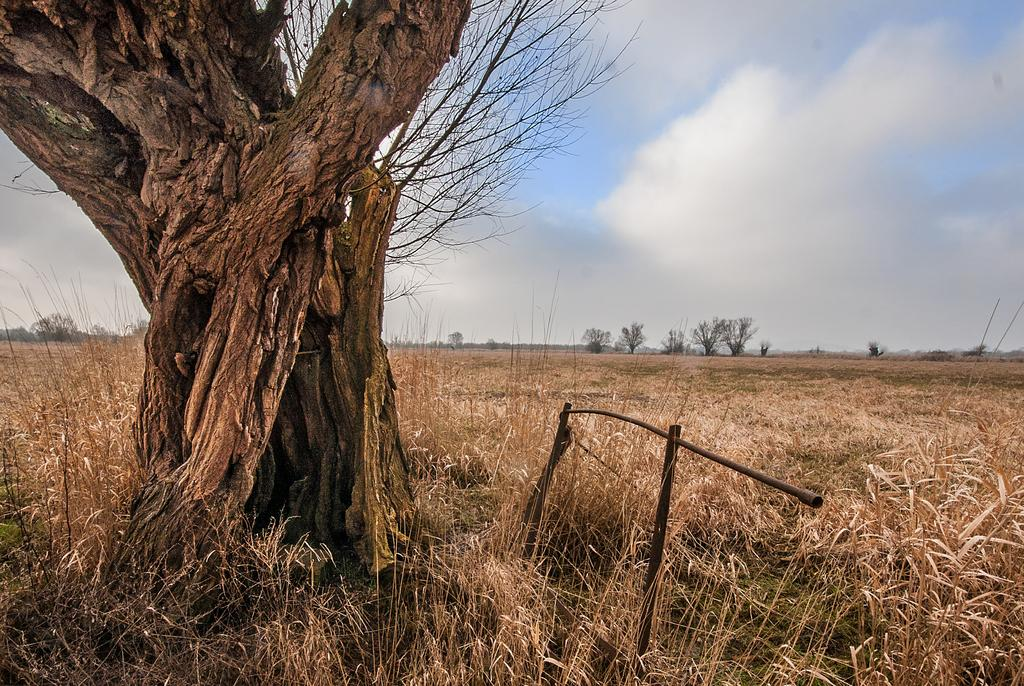What is the main object in the image? There is a tree trunk in the image. Are there any other objects related to the tree trunk? Yes, there is a rod in the image. What type of vegetation can be seen in the image? There are trees and grass visible in the image. How would you describe the weather in the image? The sky is cloudy in the image. What type of cheese is being served on the plate during the lunch in the image? There is no lunch, plate, or cheese present in the image. 